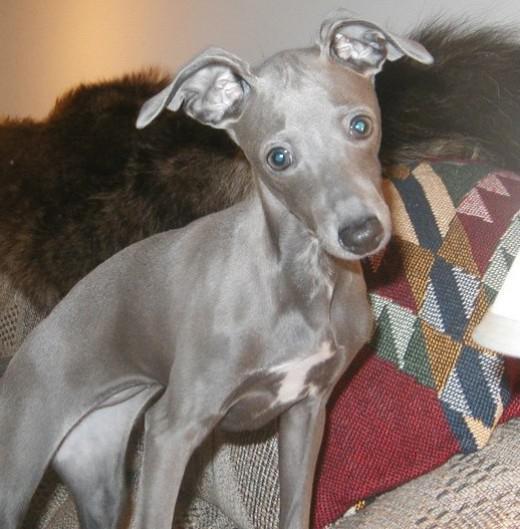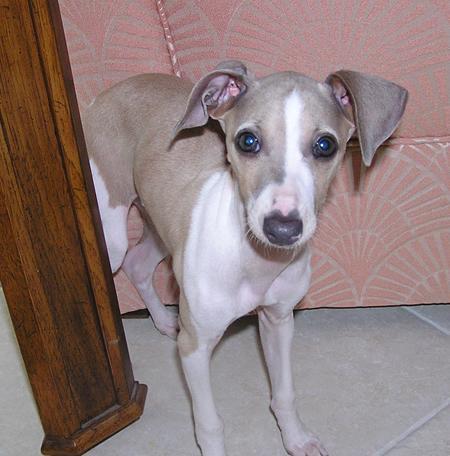The first image is the image on the left, the second image is the image on the right. Examine the images to the left and right. Is the description "The dogs in the image on the right are standing on a tiled floor." accurate? Answer yes or no. Yes. The first image is the image on the left, the second image is the image on the right. Assess this claim about the two images: "Two hounds of different colors are side-by-side on a soft surface, and at least one dog is reclining.". Correct or not? Answer yes or no. No. 